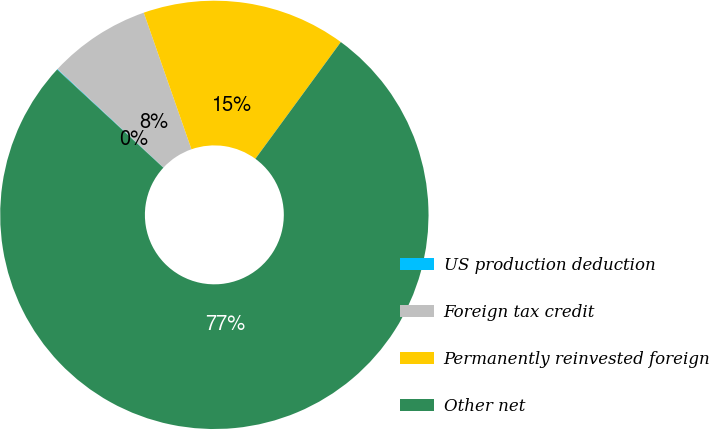Convert chart to OTSL. <chart><loc_0><loc_0><loc_500><loc_500><pie_chart><fcel>US production deduction<fcel>Foreign tax credit<fcel>Permanently reinvested foreign<fcel>Other net<nl><fcel>0.05%<fcel>7.73%<fcel>15.4%<fcel>76.81%<nl></chart> 